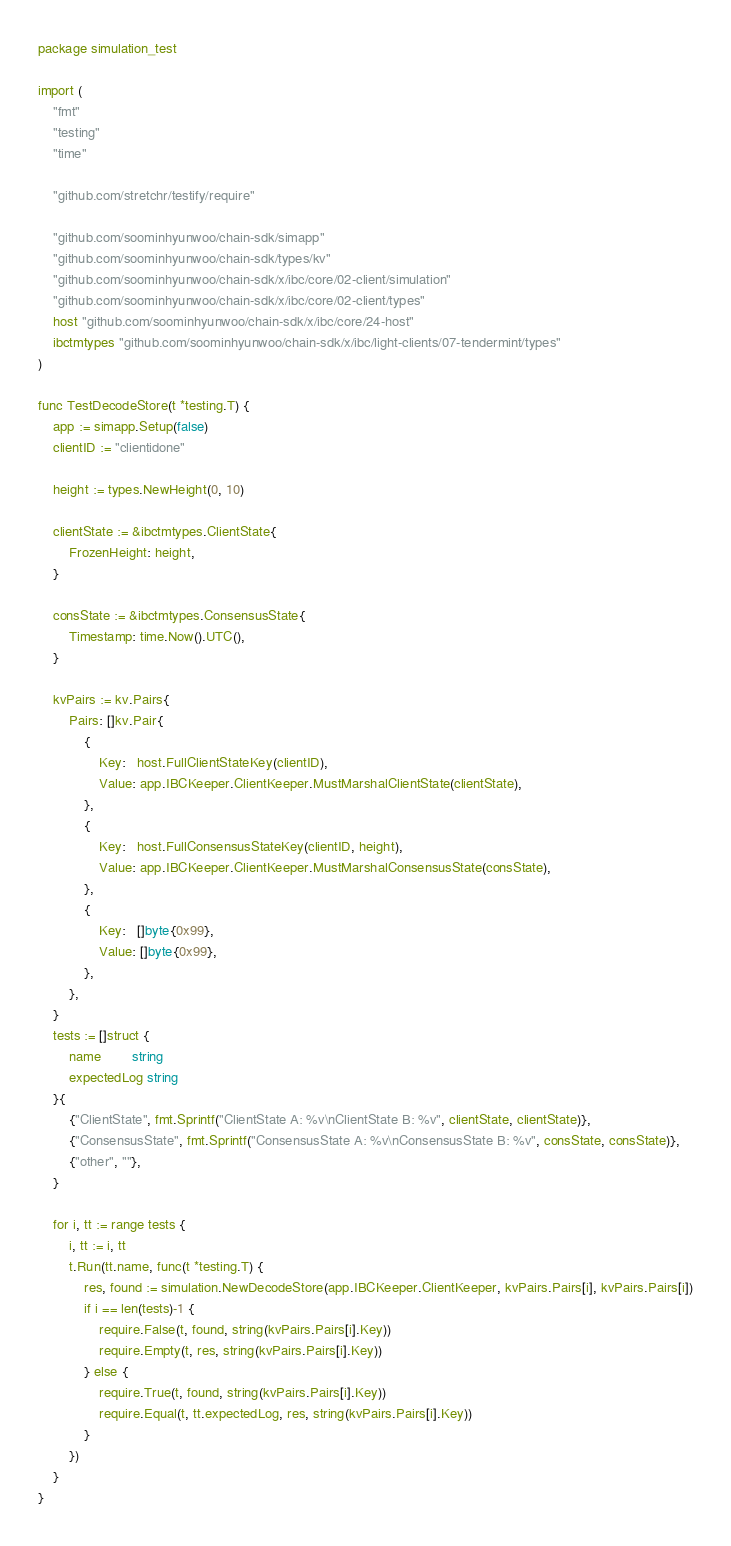<code> <loc_0><loc_0><loc_500><loc_500><_Go_>package simulation_test

import (
	"fmt"
	"testing"
	"time"

	"github.com/stretchr/testify/require"

	"github.com/soominhyunwoo/chain-sdk/simapp"
	"github.com/soominhyunwoo/chain-sdk/types/kv"
	"github.com/soominhyunwoo/chain-sdk/x/ibc/core/02-client/simulation"
	"github.com/soominhyunwoo/chain-sdk/x/ibc/core/02-client/types"
	host "github.com/soominhyunwoo/chain-sdk/x/ibc/core/24-host"
	ibctmtypes "github.com/soominhyunwoo/chain-sdk/x/ibc/light-clients/07-tendermint/types"
)

func TestDecodeStore(t *testing.T) {
	app := simapp.Setup(false)
	clientID := "clientidone"

	height := types.NewHeight(0, 10)

	clientState := &ibctmtypes.ClientState{
		FrozenHeight: height,
	}

	consState := &ibctmtypes.ConsensusState{
		Timestamp: time.Now().UTC(),
	}

	kvPairs := kv.Pairs{
		Pairs: []kv.Pair{
			{
				Key:   host.FullClientStateKey(clientID),
				Value: app.IBCKeeper.ClientKeeper.MustMarshalClientState(clientState),
			},
			{
				Key:   host.FullConsensusStateKey(clientID, height),
				Value: app.IBCKeeper.ClientKeeper.MustMarshalConsensusState(consState),
			},
			{
				Key:   []byte{0x99},
				Value: []byte{0x99},
			},
		},
	}
	tests := []struct {
		name        string
		expectedLog string
	}{
		{"ClientState", fmt.Sprintf("ClientState A: %v\nClientState B: %v", clientState, clientState)},
		{"ConsensusState", fmt.Sprintf("ConsensusState A: %v\nConsensusState B: %v", consState, consState)},
		{"other", ""},
	}

	for i, tt := range tests {
		i, tt := i, tt
		t.Run(tt.name, func(t *testing.T) {
			res, found := simulation.NewDecodeStore(app.IBCKeeper.ClientKeeper, kvPairs.Pairs[i], kvPairs.Pairs[i])
			if i == len(tests)-1 {
				require.False(t, found, string(kvPairs.Pairs[i].Key))
				require.Empty(t, res, string(kvPairs.Pairs[i].Key))
			} else {
				require.True(t, found, string(kvPairs.Pairs[i].Key))
				require.Equal(t, tt.expectedLog, res, string(kvPairs.Pairs[i].Key))
			}
		})
	}
}
</code> 